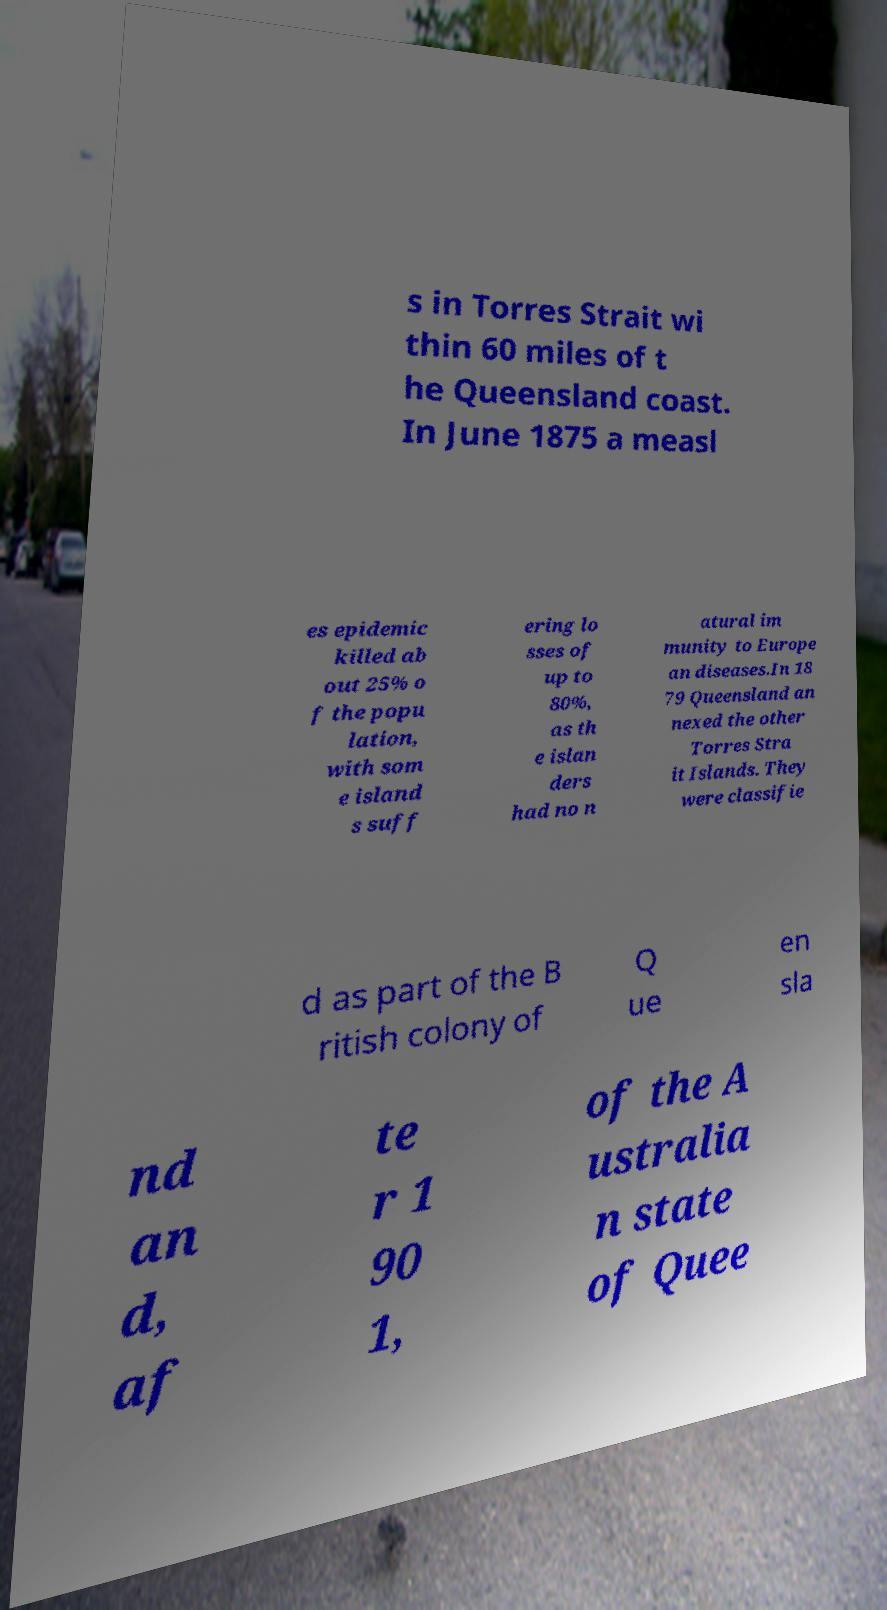I need the written content from this picture converted into text. Can you do that? s in Torres Strait wi thin 60 miles of t he Queensland coast. In June 1875 a measl es epidemic killed ab out 25% o f the popu lation, with som e island s suff ering lo sses of up to 80%, as th e islan ders had no n atural im munity to Europe an diseases.In 18 79 Queensland an nexed the other Torres Stra it Islands. They were classifie d as part of the B ritish colony of Q ue en sla nd an d, af te r 1 90 1, of the A ustralia n state of Quee 